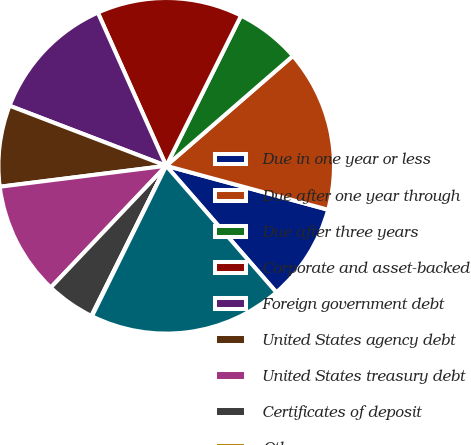Convert chart. <chart><loc_0><loc_0><loc_500><loc_500><pie_chart><fcel>Due in one year or less<fcel>Due after one year through<fcel>Due after three years<fcel>Corporate and asset-backed<fcel>Foreign government debt<fcel>United States agency debt<fcel>United States treasury debt<fcel>Certificates of deposit<fcel>Other<fcel>Total available-for-sale<nl><fcel>9.38%<fcel>15.59%<fcel>6.27%<fcel>14.04%<fcel>12.49%<fcel>7.82%<fcel>10.93%<fcel>4.72%<fcel>0.06%<fcel>18.7%<nl></chart> 